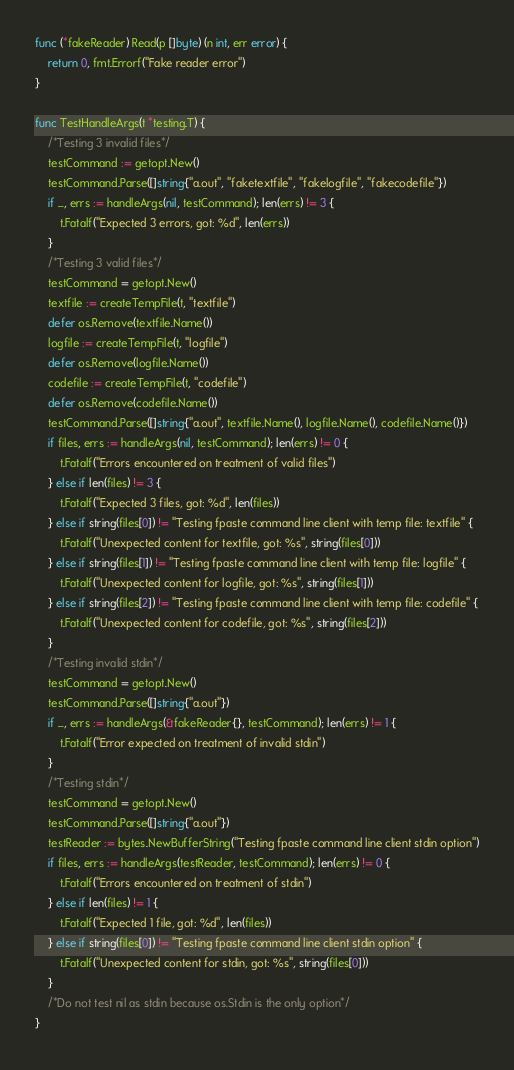<code> <loc_0><loc_0><loc_500><loc_500><_Go_>func (*fakeReader) Read(p []byte) (n int, err error) {
	return 0, fmt.Errorf("Fake reader error")
}

func TestHandleArgs(t *testing.T) {
	/*Testing 3 invalid files*/
	testCommand := getopt.New()
	testCommand.Parse([]string{"a.out", "faketextfile", "fakelogfile", "fakecodefile"})
	if _, errs := handleArgs(nil, testCommand); len(errs) != 3 {
		t.Fatalf("Expected 3 errors, got: %d", len(errs))
	}
	/*Testing 3 valid files*/
	testCommand = getopt.New()
	textfile := createTempFile(t, "textfile")
	defer os.Remove(textfile.Name())
	logfile := createTempFile(t, "logfile")
	defer os.Remove(logfile.Name())
	codefile := createTempFile(t, "codefile")
	defer os.Remove(codefile.Name())
	testCommand.Parse([]string{"a.out", textfile.Name(), logfile.Name(), codefile.Name()})
	if files, errs := handleArgs(nil, testCommand); len(errs) != 0 {
		t.Fatalf("Errors encountered on treatment of valid files")
	} else if len(files) != 3 {
		t.Fatalf("Expected 3 files, got: %d", len(files))
	} else if string(files[0]) != "Testing fpaste command line client with temp file: textfile" {
		t.Fatalf("Unexpected content for textfile, got: %s", string(files[0]))
	} else if string(files[1]) != "Testing fpaste command line client with temp file: logfile" {
		t.Fatalf("Unexpected content for logfile, got: %s", string(files[1]))
	} else if string(files[2]) != "Testing fpaste command line client with temp file: codefile" {
		t.Fatalf("Unexpected content for codefile, got: %s", string(files[2]))
	}
	/*Testing invalid stdin*/
	testCommand = getopt.New()
	testCommand.Parse([]string{"a.out"})
	if _, errs := handleArgs(&fakeReader{}, testCommand); len(errs) != 1 {
		t.Fatalf("Error expected on treatment of invalid stdin")
	}
	/*Testing stdin*/
	testCommand = getopt.New()
	testCommand.Parse([]string{"a.out"})
	testReader := bytes.NewBufferString("Testing fpaste command line client stdin option")
	if files, errs := handleArgs(testReader, testCommand); len(errs) != 0 {
		t.Fatalf("Errors encountered on treatment of stdin")
	} else if len(files) != 1 {
		t.Fatalf("Expected 1 file, got: %d", len(files))
	} else if string(files[0]) != "Testing fpaste command line client stdin option" {
		t.Fatalf("Unexpected content for stdin, got: %s", string(files[0]))
	}
	/*Do not test nil as stdin because os.Stdin is the only option*/
}
</code> 